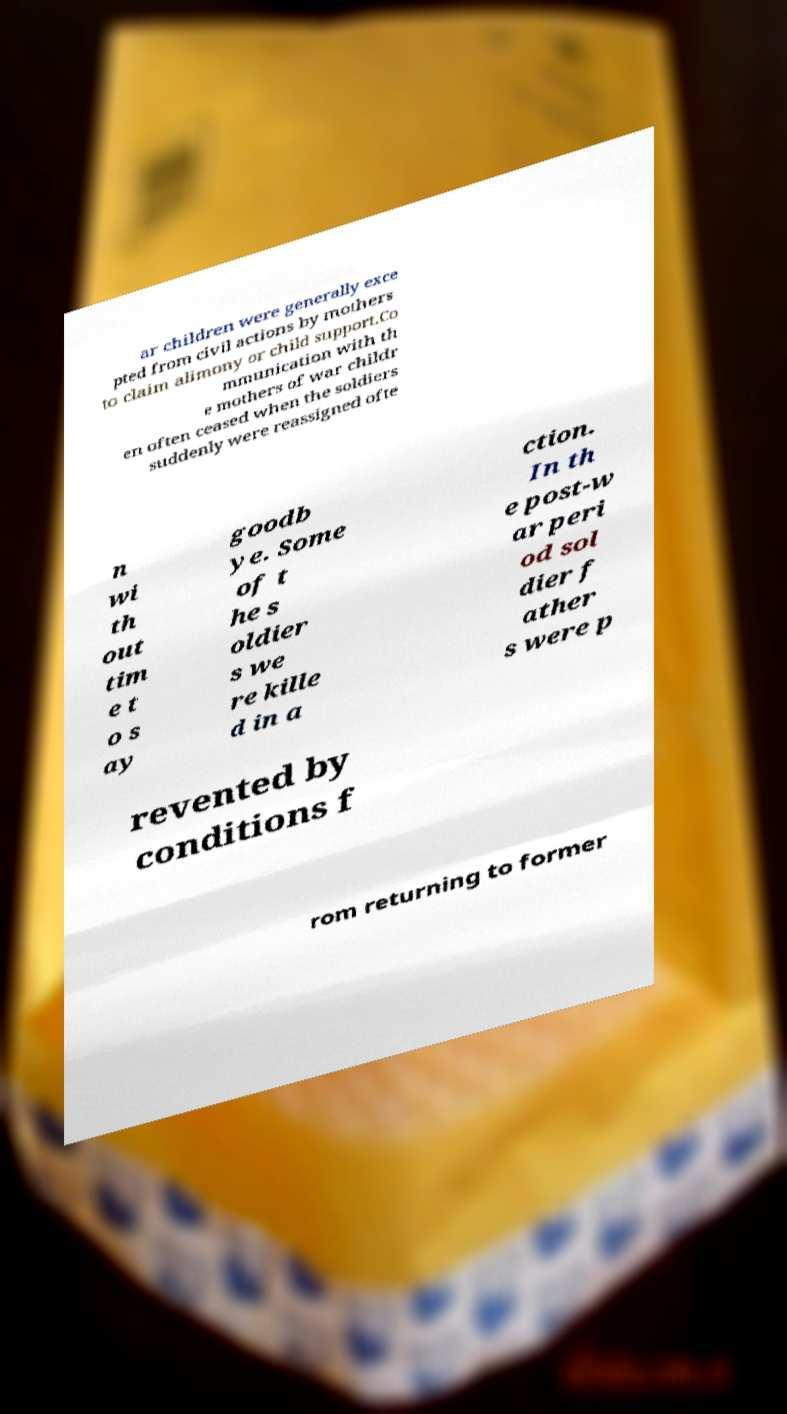Please identify and transcribe the text found in this image. ar children were generally exce pted from civil actions by mothers to claim alimony or child support.Co mmunication with th e mothers of war childr en often ceased when the soldiers suddenly were reassigned ofte n wi th out tim e t o s ay goodb ye. Some of t he s oldier s we re kille d in a ction. In th e post-w ar peri od sol dier f ather s were p revented by conditions f rom returning to former 